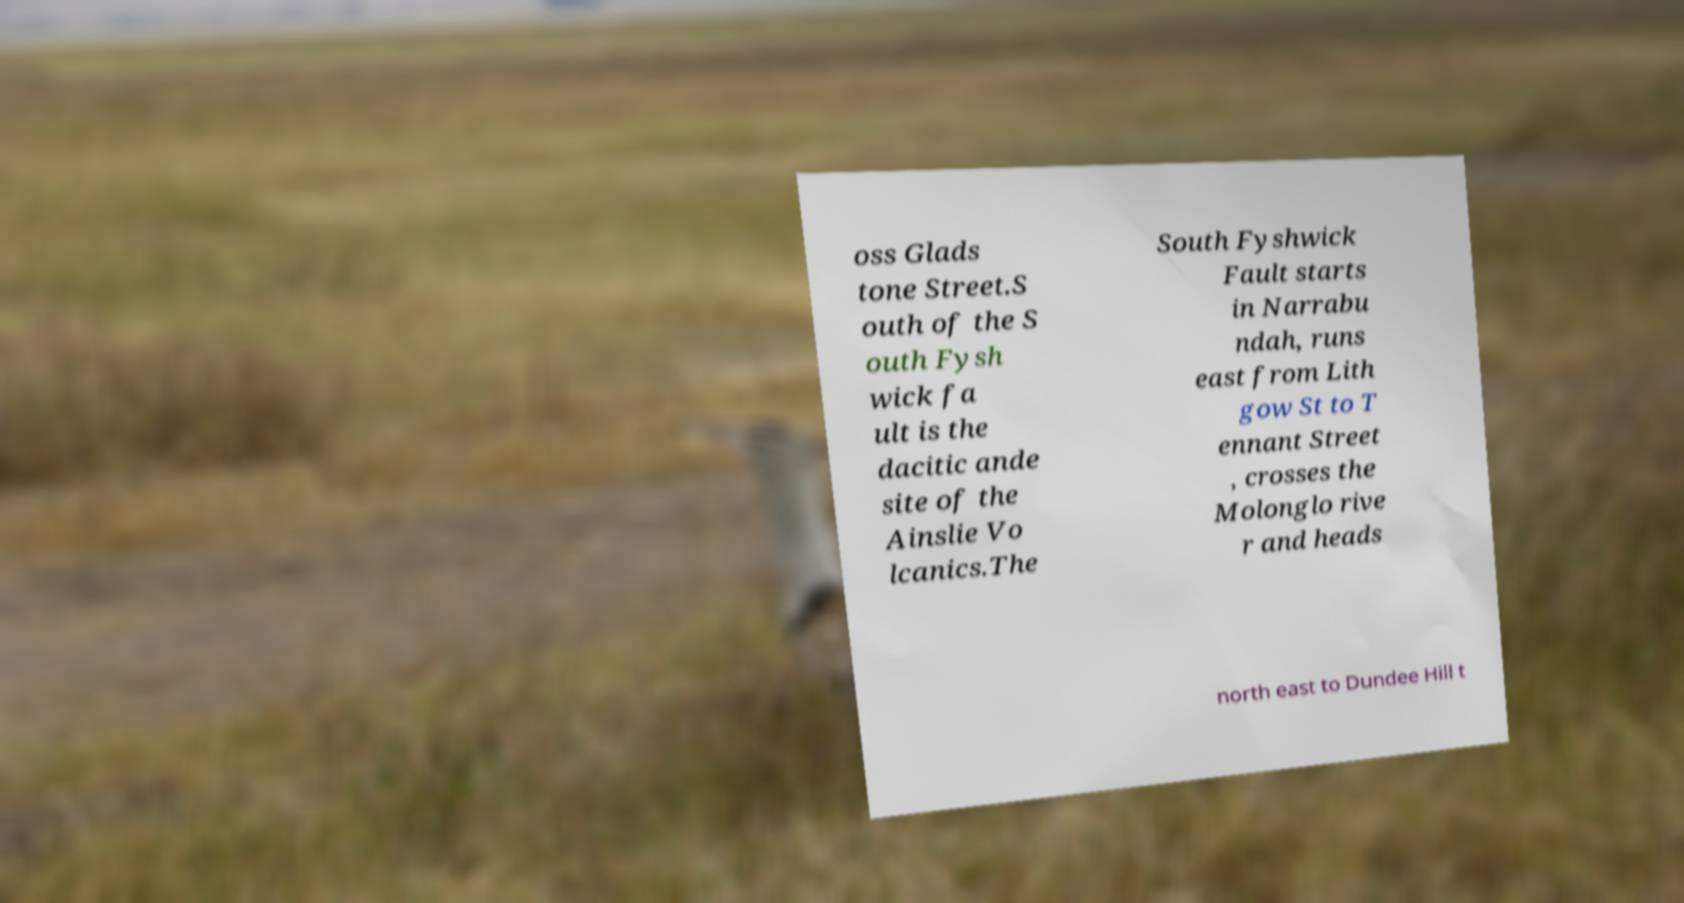Can you read and provide the text displayed in the image?This photo seems to have some interesting text. Can you extract and type it out for me? oss Glads tone Street.S outh of the S outh Fysh wick fa ult is the dacitic ande site of the Ainslie Vo lcanics.The South Fyshwick Fault starts in Narrabu ndah, runs east from Lith gow St to T ennant Street , crosses the Molonglo rive r and heads north east to Dundee Hill t 